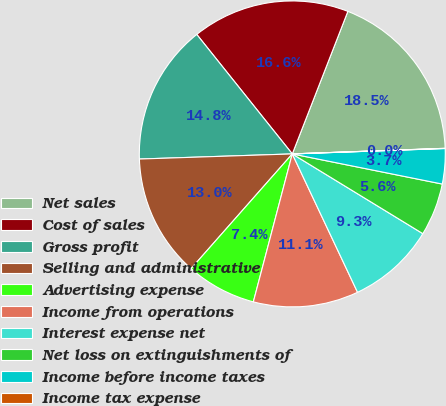Convert chart. <chart><loc_0><loc_0><loc_500><loc_500><pie_chart><fcel>Net sales<fcel>Cost of sales<fcel>Gross profit<fcel>Selling and administrative<fcel>Advertising expense<fcel>Income from operations<fcel>Interest expense net<fcel>Net loss on extinguishments of<fcel>Income before income taxes<fcel>Income tax expense<nl><fcel>18.5%<fcel>16.65%<fcel>14.8%<fcel>12.96%<fcel>7.41%<fcel>11.11%<fcel>9.26%<fcel>5.57%<fcel>3.72%<fcel>0.02%<nl></chart> 